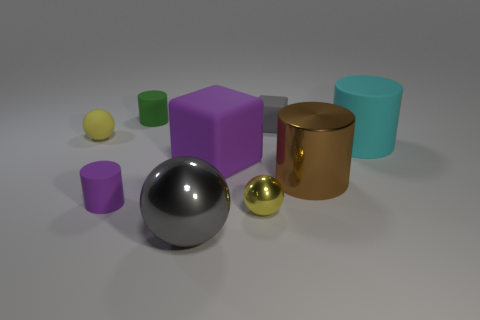Is the tiny shiny sphere the same color as the tiny matte ball?
Your answer should be compact. Yes. Are there any other things that have the same material as the cyan cylinder?
Offer a very short reply. Yes. What number of objects are yellow things that are to the right of the small green thing or cylinders to the left of the tiny shiny sphere?
Provide a short and direct response. 3. Is the small purple object made of the same material as the small yellow thing to the left of the small yellow shiny thing?
Make the answer very short. Yes. The matte object that is in front of the cyan cylinder and on the right side of the small green rubber cylinder has what shape?
Keep it short and to the point. Cube. What number of other objects are the same color as the small block?
Offer a very short reply. 1. The cyan rubber object is what shape?
Your response must be concise. Cylinder. There is a big object that is to the left of the rubber block in front of the tiny gray rubber block; what is its color?
Ensure brevity in your answer.  Gray. There is a big metallic sphere; is it the same color as the metallic sphere that is right of the big gray ball?
Your response must be concise. No. The small thing that is behind the small purple matte cylinder and on the right side of the tiny green cylinder is made of what material?
Offer a terse response. Rubber. 